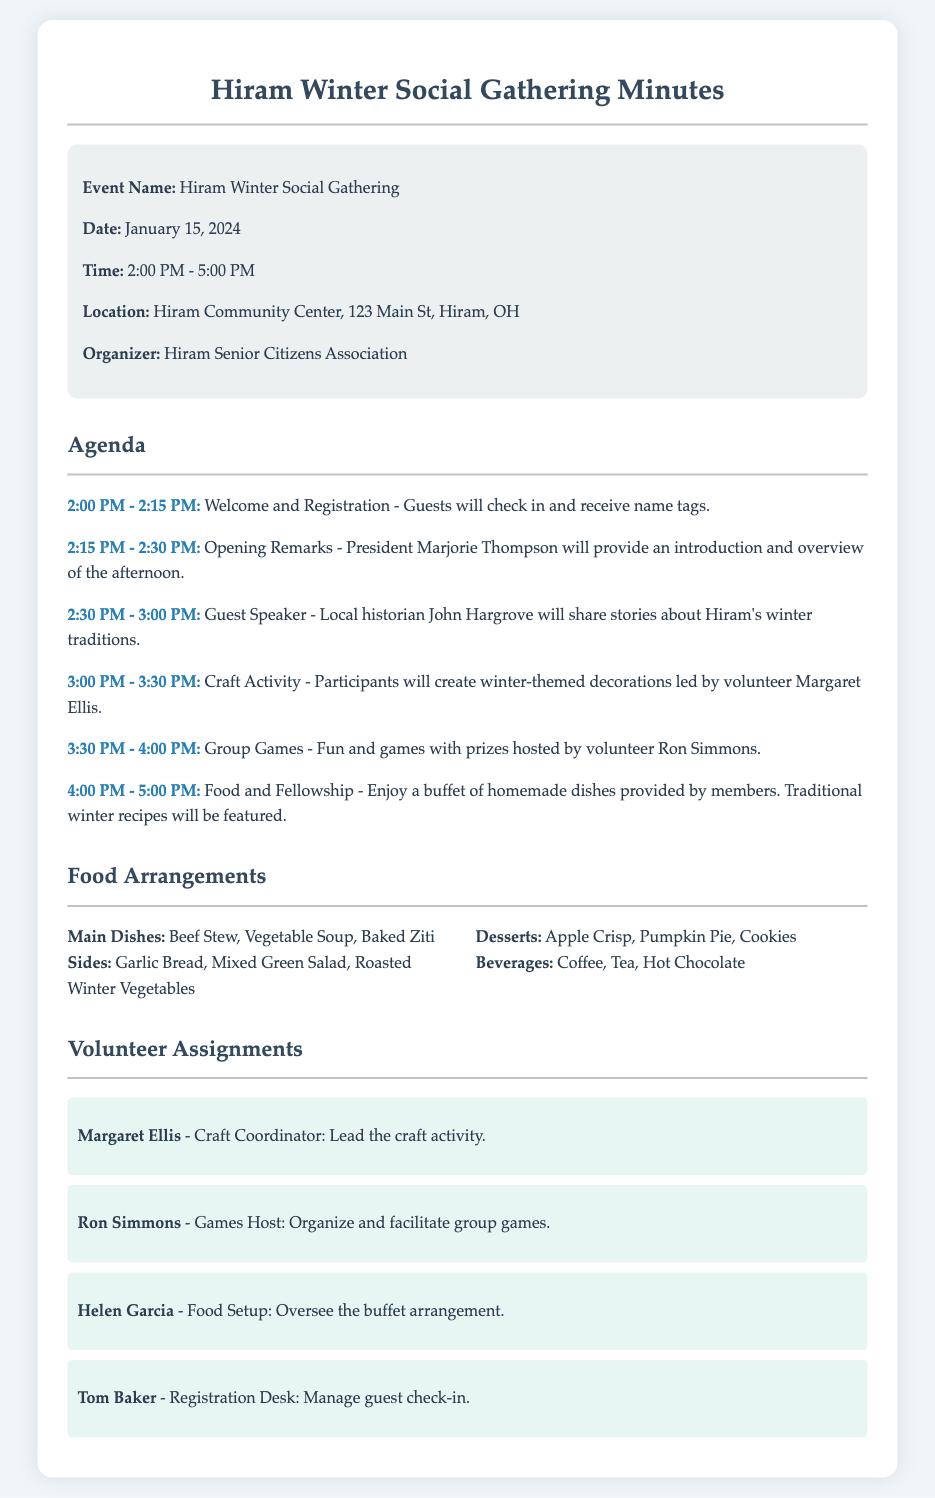What is the event name? The event name is clearly stated in the document.
Answer: Hiram Winter Social Gathering What is the date of the event? The date can be found in the event details section.
Answer: January 15, 2024 Who will provide the opening remarks? The document mentions the name of the person responsible for the opening remarks.
Answer: Marjorie Thompson What time does the food and fellowship start? The schedule indicates when the food and fellowship activity begins.
Answer: 4:00 PM How many main dishes are listed? The list of food arrangements provides the number of main dishes.
Answer: Three Who is responsible for the craft activity? The volunteer assignment section specifies who leads the craft activity.
Answer: Margaret Ellis What type of soup is included on the food list? The food arrangements section lists types of soups being served.
Answer: Vegetable Soup What activity is scheduled just before the food and fellowship? The agenda outlines the sequence of activities leading up to food and fellowship.
Answer: Group Games How long is the winter social gathering scheduled for? The total time span of the event is included in the event details.
Answer: Three hours 